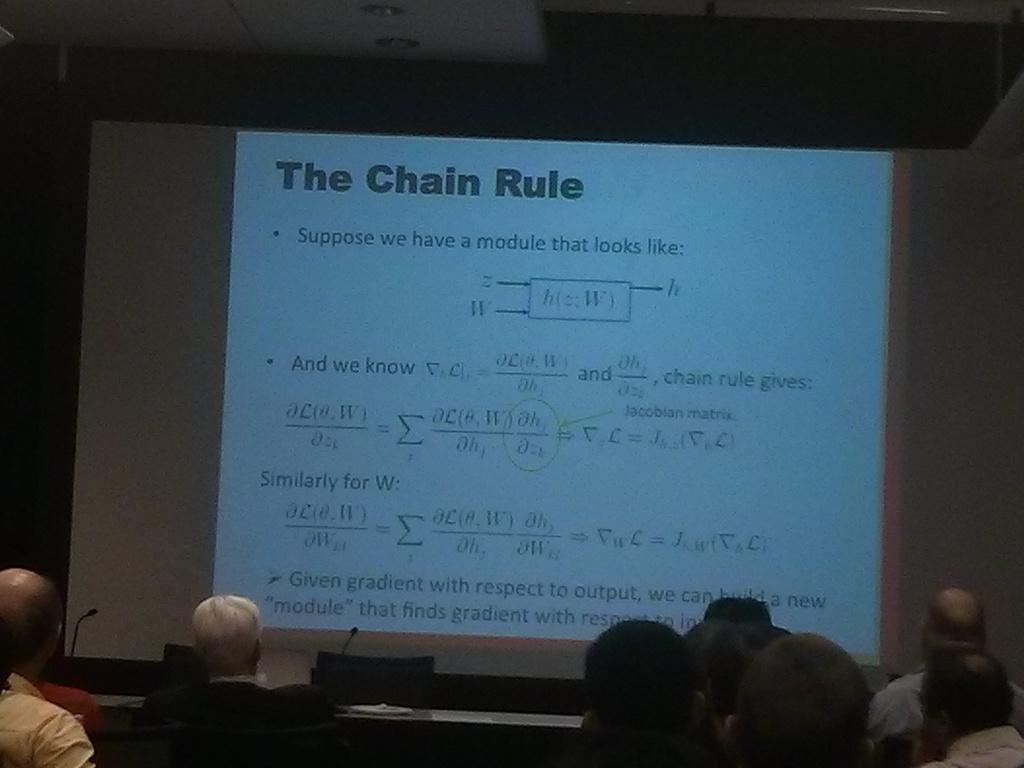What is the main activity of the people in the image? There are many people sitting in the image, which suggests they might be attending an event or gathering. What type of furniture is present in the image? There are chairs in the image. What can be found on the tables in the image? There are tables with microphones in the image. What is on the wall in the image? There is a wall with a screen in the image. What is written or displayed on the screen? Something is written on the screen. What type of suit is the scale wearing in the image? There is no suit or scale present in the image. 